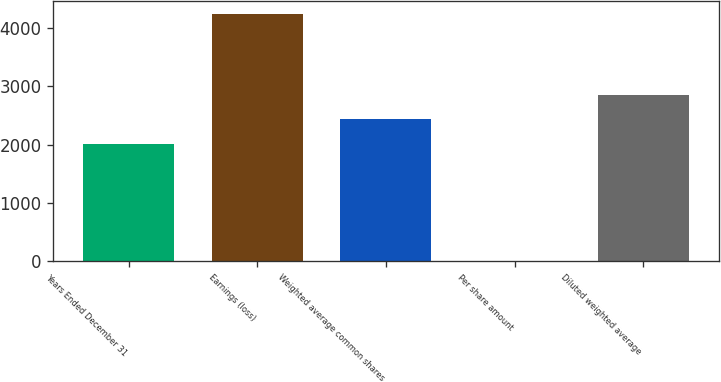Convert chart. <chart><loc_0><loc_0><loc_500><loc_500><bar_chart><fcel>Years Ended December 31<fcel>Earnings (loss)<fcel>Weighted average common shares<fcel>Per share amount<fcel>Diluted weighted average<nl><fcel>2008<fcel>4244<fcel>2432.21<fcel>1.87<fcel>2856.42<nl></chart> 